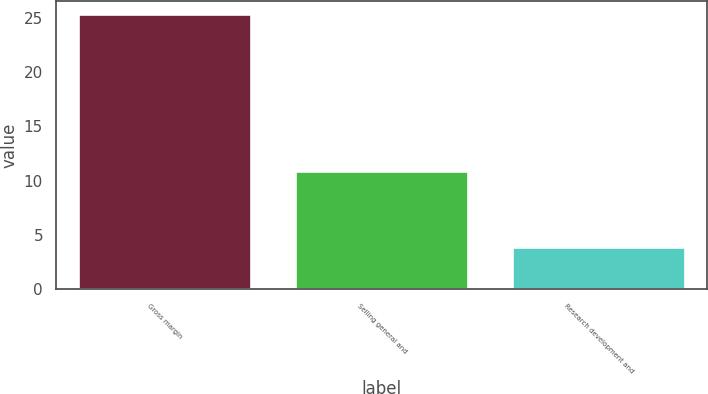Convert chart. <chart><loc_0><loc_0><loc_500><loc_500><bar_chart><fcel>Gross margin<fcel>Selling general and<fcel>Research development and<nl><fcel>25.3<fcel>10.9<fcel>3.9<nl></chart> 